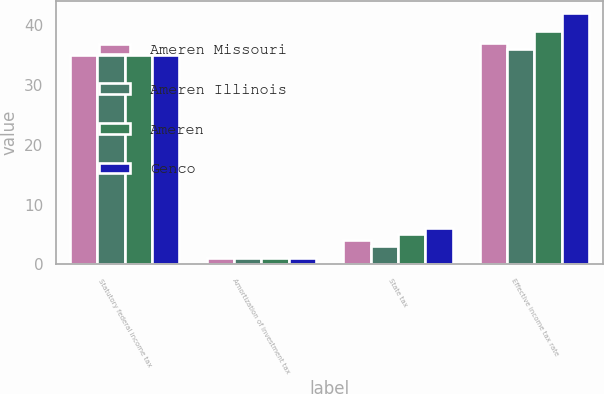Convert chart to OTSL. <chart><loc_0><loc_0><loc_500><loc_500><stacked_bar_chart><ecel><fcel>Statutory federal income tax<fcel>Amortization of investment tax<fcel>State tax<fcel>Effective income tax rate<nl><fcel>Ameren Missouri<fcel>35<fcel>1<fcel>4<fcel>37<nl><fcel>Ameren Illinois<fcel>35<fcel>1<fcel>3<fcel>36<nl><fcel>Ameren<fcel>35<fcel>1<fcel>5<fcel>39<nl><fcel>Genco<fcel>35<fcel>1<fcel>6<fcel>42<nl></chart> 